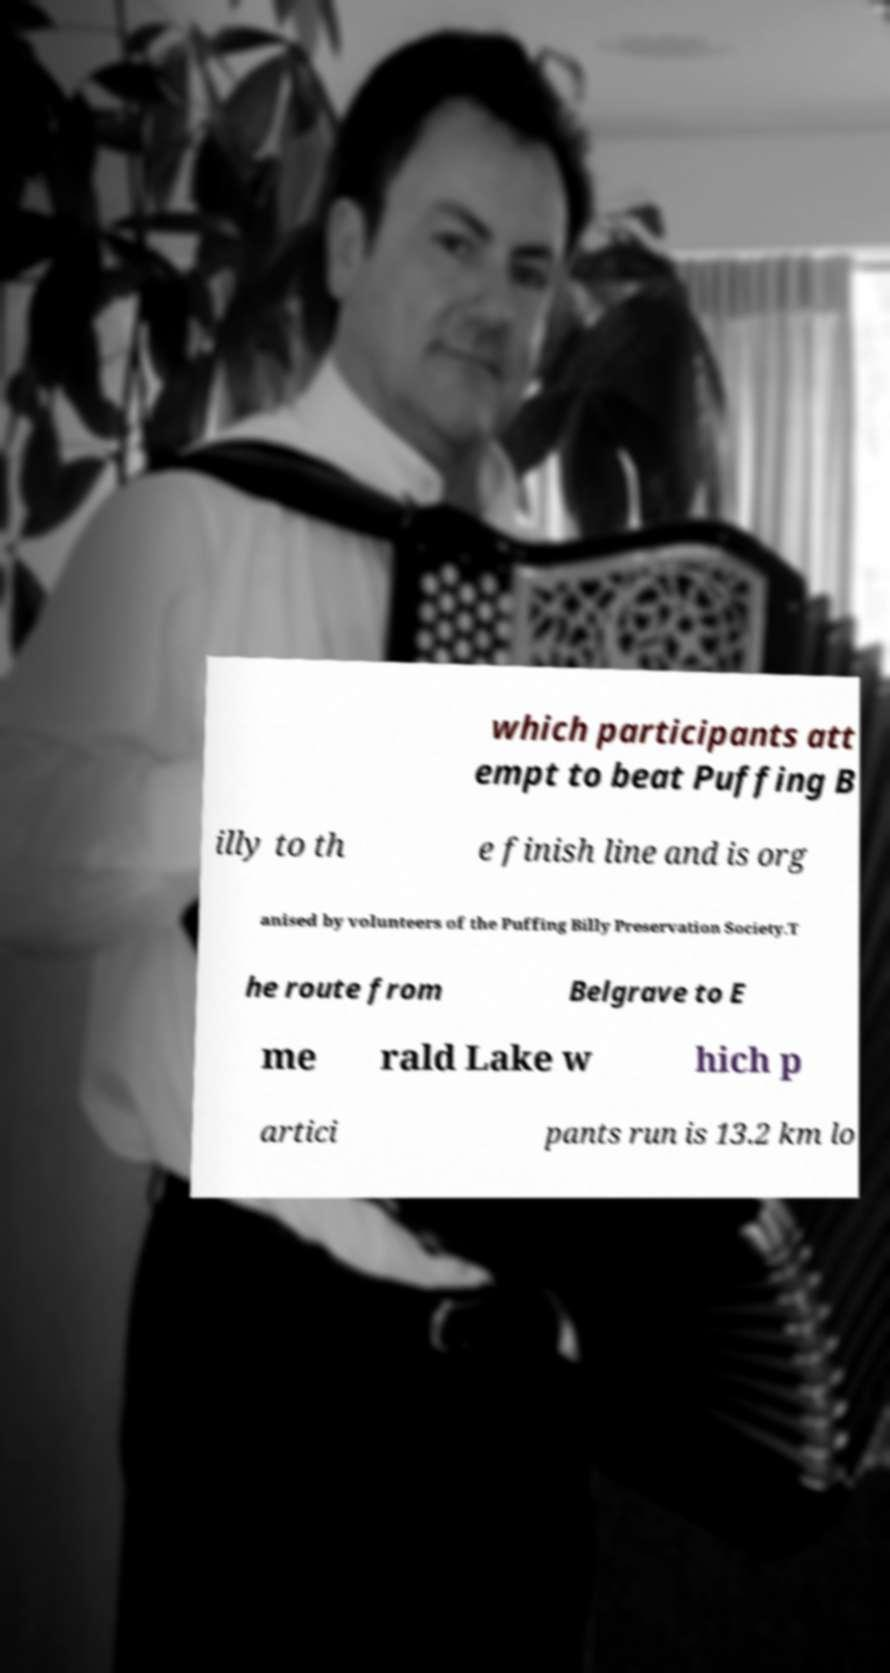Can you read and provide the text displayed in the image?This photo seems to have some interesting text. Can you extract and type it out for me? which participants att empt to beat Puffing B illy to th e finish line and is org anised by volunteers of the Puffing Billy Preservation Society.T he route from Belgrave to E me rald Lake w hich p artici pants run is 13.2 km lo 